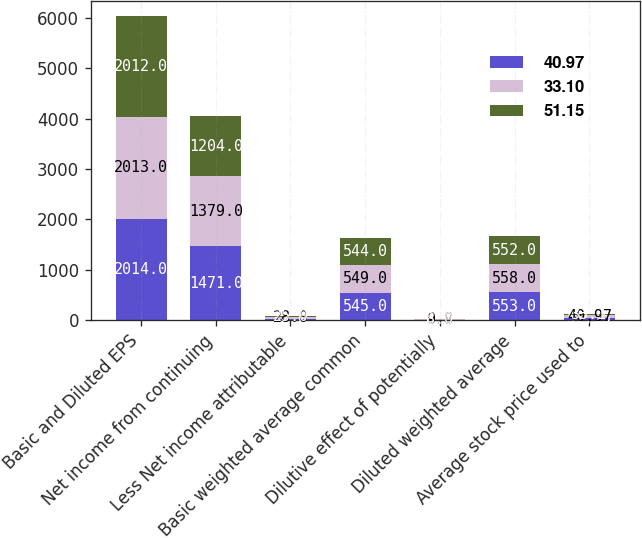Convert chart to OTSL. <chart><loc_0><loc_0><loc_500><loc_500><stacked_bar_chart><ecel><fcel>Basic and Diluted EPS<fcel>Net income from continuing<fcel>Less Net income attributable<fcel>Basic weighted average common<fcel>Dilutive effect of potentially<fcel>Diluted weighted average<fcel>Average stock price used to<nl><fcel>40.97<fcel>2014<fcel>1471<fcel>32<fcel>545<fcel>8<fcel>553<fcel>51.15<nl><fcel>33.1<fcel>2013<fcel>1379<fcel>28<fcel>549<fcel>9<fcel>558<fcel>40.97<nl><fcel>51.15<fcel>2012<fcel>1204<fcel>25<fcel>544<fcel>8<fcel>552<fcel>33.1<nl></chart> 